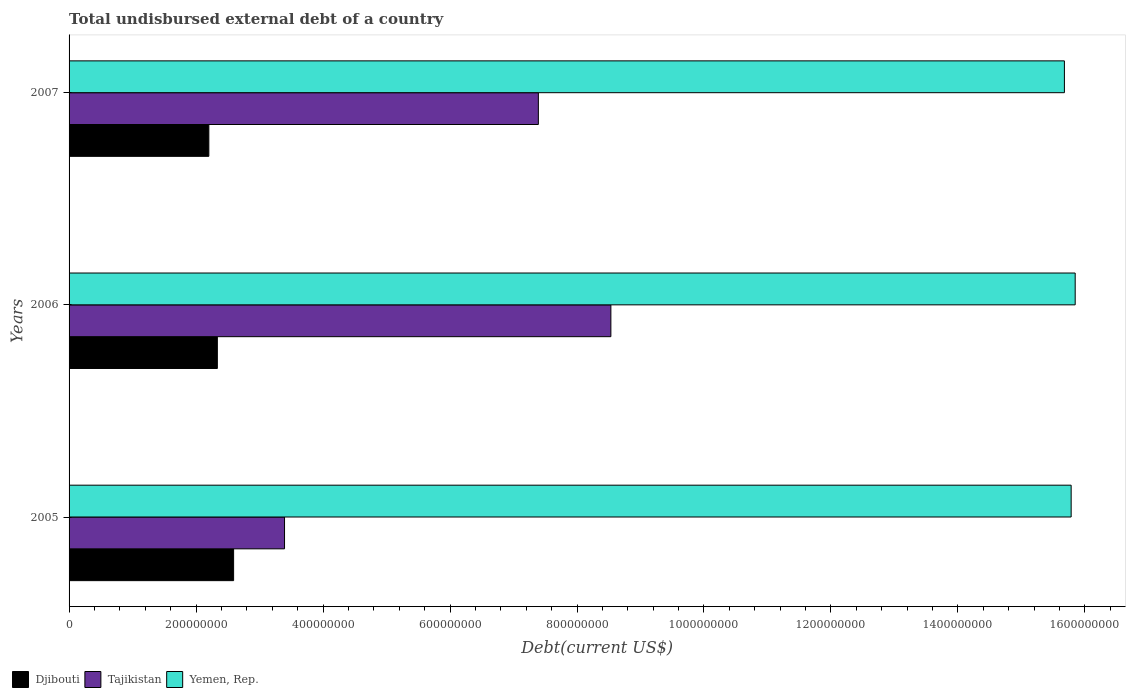How many groups of bars are there?
Provide a succinct answer. 3. Are the number of bars per tick equal to the number of legend labels?
Offer a very short reply. Yes. In how many cases, is the number of bars for a given year not equal to the number of legend labels?
Give a very brief answer. 0. What is the total undisbursed external debt in Yemen, Rep. in 2006?
Your answer should be very brief. 1.58e+09. Across all years, what is the maximum total undisbursed external debt in Yemen, Rep.?
Keep it short and to the point. 1.58e+09. Across all years, what is the minimum total undisbursed external debt in Yemen, Rep.?
Provide a short and direct response. 1.57e+09. In which year was the total undisbursed external debt in Yemen, Rep. maximum?
Ensure brevity in your answer.  2006. What is the total total undisbursed external debt in Djibouti in the graph?
Your answer should be compact. 7.13e+08. What is the difference between the total undisbursed external debt in Djibouti in 2005 and that in 2007?
Offer a very short reply. 3.90e+07. What is the difference between the total undisbursed external debt in Yemen, Rep. in 2006 and the total undisbursed external debt in Djibouti in 2007?
Your response must be concise. 1.36e+09. What is the average total undisbursed external debt in Yemen, Rep. per year?
Keep it short and to the point. 1.58e+09. In the year 2005, what is the difference between the total undisbursed external debt in Djibouti and total undisbursed external debt in Yemen, Rep.?
Your response must be concise. -1.32e+09. In how many years, is the total undisbursed external debt in Yemen, Rep. greater than 1360000000 US$?
Offer a terse response. 3. What is the ratio of the total undisbursed external debt in Tajikistan in 2005 to that in 2007?
Give a very brief answer. 0.46. Is the difference between the total undisbursed external debt in Djibouti in 2005 and 2007 greater than the difference between the total undisbursed external debt in Yemen, Rep. in 2005 and 2007?
Provide a succinct answer. Yes. What is the difference between the highest and the second highest total undisbursed external debt in Yemen, Rep.?
Your response must be concise. 6.36e+06. What is the difference between the highest and the lowest total undisbursed external debt in Djibouti?
Keep it short and to the point. 3.90e+07. In how many years, is the total undisbursed external debt in Yemen, Rep. greater than the average total undisbursed external debt in Yemen, Rep. taken over all years?
Ensure brevity in your answer.  2. What does the 3rd bar from the top in 2005 represents?
Give a very brief answer. Djibouti. What does the 1st bar from the bottom in 2006 represents?
Offer a terse response. Djibouti. Are all the bars in the graph horizontal?
Your answer should be compact. Yes. How many years are there in the graph?
Your answer should be compact. 3. What is the difference between two consecutive major ticks on the X-axis?
Offer a very short reply. 2.00e+08. Does the graph contain any zero values?
Your response must be concise. No. How many legend labels are there?
Keep it short and to the point. 3. What is the title of the graph?
Ensure brevity in your answer.  Total undisbursed external debt of a country. What is the label or title of the X-axis?
Make the answer very short. Debt(current US$). What is the label or title of the Y-axis?
Offer a terse response. Years. What is the Debt(current US$) in Djibouti in 2005?
Provide a succinct answer. 2.59e+08. What is the Debt(current US$) of Tajikistan in 2005?
Offer a terse response. 3.39e+08. What is the Debt(current US$) in Yemen, Rep. in 2005?
Make the answer very short. 1.58e+09. What is the Debt(current US$) in Djibouti in 2006?
Ensure brevity in your answer.  2.34e+08. What is the Debt(current US$) in Tajikistan in 2006?
Your answer should be compact. 8.53e+08. What is the Debt(current US$) in Yemen, Rep. in 2006?
Ensure brevity in your answer.  1.58e+09. What is the Debt(current US$) of Djibouti in 2007?
Your answer should be very brief. 2.20e+08. What is the Debt(current US$) in Tajikistan in 2007?
Your response must be concise. 7.39e+08. What is the Debt(current US$) of Yemen, Rep. in 2007?
Keep it short and to the point. 1.57e+09. Across all years, what is the maximum Debt(current US$) of Djibouti?
Your response must be concise. 2.59e+08. Across all years, what is the maximum Debt(current US$) of Tajikistan?
Offer a terse response. 8.53e+08. Across all years, what is the maximum Debt(current US$) in Yemen, Rep.?
Keep it short and to the point. 1.58e+09. Across all years, what is the minimum Debt(current US$) in Djibouti?
Your response must be concise. 2.20e+08. Across all years, what is the minimum Debt(current US$) in Tajikistan?
Offer a very short reply. 3.39e+08. Across all years, what is the minimum Debt(current US$) in Yemen, Rep.?
Provide a short and direct response. 1.57e+09. What is the total Debt(current US$) of Djibouti in the graph?
Ensure brevity in your answer.  7.13e+08. What is the total Debt(current US$) of Tajikistan in the graph?
Offer a terse response. 1.93e+09. What is the total Debt(current US$) in Yemen, Rep. in the graph?
Your answer should be compact. 4.73e+09. What is the difference between the Debt(current US$) in Djibouti in 2005 and that in 2006?
Offer a terse response. 2.56e+07. What is the difference between the Debt(current US$) of Tajikistan in 2005 and that in 2006?
Offer a terse response. -5.14e+08. What is the difference between the Debt(current US$) in Yemen, Rep. in 2005 and that in 2006?
Provide a short and direct response. -6.36e+06. What is the difference between the Debt(current US$) in Djibouti in 2005 and that in 2007?
Your response must be concise. 3.90e+07. What is the difference between the Debt(current US$) in Tajikistan in 2005 and that in 2007?
Offer a very short reply. -4.00e+08. What is the difference between the Debt(current US$) of Yemen, Rep. in 2005 and that in 2007?
Your answer should be compact. 1.06e+07. What is the difference between the Debt(current US$) in Djibouti in 2006 and that in 2007?
Give a very brief answer. 1.34e+07. What is the difference between the Debt(current US$) in Tajikistan in 2006 and that in 2007?
Offer a very short reply. 1.14e+08. What is the difference between the Debt(current US$) in Yemen, Rep. in 2006 and that in 2007?
Offer a terse response. 1.70e+07. What is the difference between the Debt(current US$) in Djibouti in 2005 and the Debt(current US$) in Tajikistan in 2006?
Keep it short and to the point. -5.94e+08. What is the difference between the Debt(current US$) in Djibouti in 2005 and the Debt(current US$) in Yemen, Rep. in 2006?
Offer a very short reply. -1.33e+09. What is the difference between the Debt(current US$) in Tajikistan in 2005 and the Debt(current US$) in Yemen, Rep. in 2006?
Ensure brevity in your answer.  -1.25e+09. What is the difference between the Debt(current US$) in Djibouti in 2005 and the Debt(current US$) in Tajikistan in 2007?
Ensure brevity in your answer.  -4.80e+08. What is the difference between the Debt(current US$) of Djibouti in 2005 and the Debt(current US$) of Yemen, Rep. in 2007?
Provide a succinct answer. -1.31e+09. What is the difference between the Debt(current US$) of Tajikistan in 2005 and the Debt(current US$) of Yemen, Rep. in 2007?
Make the answer very short. -1.23e+09. What is the difference between the Debt(current US$) of Djibouti in 2006 and the Debt(current US$) of Tajikistan in 2007?
Offer a very short reply. -5.06e+08. What is the difference between the Debt(current US$) in Djibouti in 2006 and the Debt(current US$) in Yemen, Rep. in 2007?
Ensure brevity in your answer.  -1.33e+09. What is the difference between the Debt(current US$) of Tajikistan in 2006 and the Debt(current US$) of Yemen, Rep. in 2007?
Your answer should be compact. -7.14e+08. What is the average Debt(current US$) of Djibouti per year?
Give a very brief answer. 2.38e+08. What is the average Debt(current US$) in Tajikistan per year?
Your answer should be very brief. 6.44e+08. What is the average Debt(current US$) of Yemen, Rep. per year?
Provide a succinct answer. 1.58e+09. In the year 2005, what is the difference between the Debt(current US$) of Djibouti and Debt(current US$) of Tajikistan?
Offer a very short reply. -8.02e+07. In the year 2005, what is the difference between the Debt(current US$) in Djibouti and Debt(current US$) in Yemen, Rep.?
Your answer should be very brief. -1.32e+09. In the year 2005, what is the difference between the Debt(current US$) in Tajikistan and Debt(current US$) in Yemen, Rep.?
Offer a very short reply. -1.24e+09. In the year 2006, what is the difference between the Debt(current US$) of Djibouti and Debt(current US$) of Tajikistan?
Keep it short and to the point. -6.20e+08. In the year 2006, what is the difference between the Debt(current US$) of Djibouti and Debt(current US$) of Yemen, Rep.?
Ensure brevity in your answer.  -1.35e+09. In the year 2006, what is the difference between the Debt(current US$) in Tajikistan and Debt(current US$) in Yemen, Rep.?
Your answer should be very brief. -7.31e+08. In the year 2007, what is the difference between the Debt(current US$) in Djibouti and Debt(current US$) in Tajikistan?
Make the answer very short. -5.19e+08. In the year 2007, what is the difference between the Debt(current US$) in Djibouti and Debt(current US$) in Yemen, Rep.?
Offer a terse response. -1.35e+09. In the year 2007, what is the difference between the Debt(current US$) in Tajikistan and Debt(current US$) in Yemen, Rep.?
Your response must be concise. -8.29e+08. What is the ratio of the Debt(current US$) in Djibouti in 2005 to that in 2006?
Ensure brevity in your answer.  1.11. What is the ratio of the Debt(current US$) in Tajikistan in 2005 to that in 2006?
Give a very brief answer. 0.4. What is the ratio of the Debt(current US$) in Yemen, Rep. in 2005 to that in 2006?
Offer a very short reply. 1. What is the ratio of the Debt(current US$) in Djibouti in 2005 to that in 2007?
Make the answer very short. 1.18. What is the ratio of the Debt(current US$) in Tajikistan in 2005 to that in 2007?
Keep it short and to the point. 0.46. What is the ratio of the Debt(current US$) in Yemen, Rep. in 2005 to that in 2007?
Your response must be concise. 1.01. What is the ratio of the Debt(current US$) of Djibouti in 2006 to that in 2007?
Offer a terse response. 1.06. What is the ratio of the Debt(current US$) in Tajikistan in 2006 to that in 2007?
Offer a very short reply. 1.15. What is the ratio of the Debt(current US$) of Yemen, Rep. in 2006 to that in 2007?
Ensure brevity in your answer.  1.01. What is the difference between the highest and the second highest Debt(current US$) of Djibouti?
Provide a short and direct response. 2.56e+07. What is the difference between the highest and the second highest Debt(current US$) in Tajikistan?
Provide a succinct answer. 1.14e+08. What is the difference between the highest and the second highest Debt(current US$) of Yemen, Rep.?
Provide a succinct answer. 6.36e+06. What is the difference between the highest and the lowest Debt(current US$) of Djibouti?
Make the answer very short. 3.90e+07. What is the difference between the highest and the lowest Debt(current US$) of Tajikistan?
Make the answer very short. 5.14e+08. What is the difference between the highest and the lowest Debt(current US$) in Yemen, Rep.?
Your answer should be very brief. 1.70e+07. 